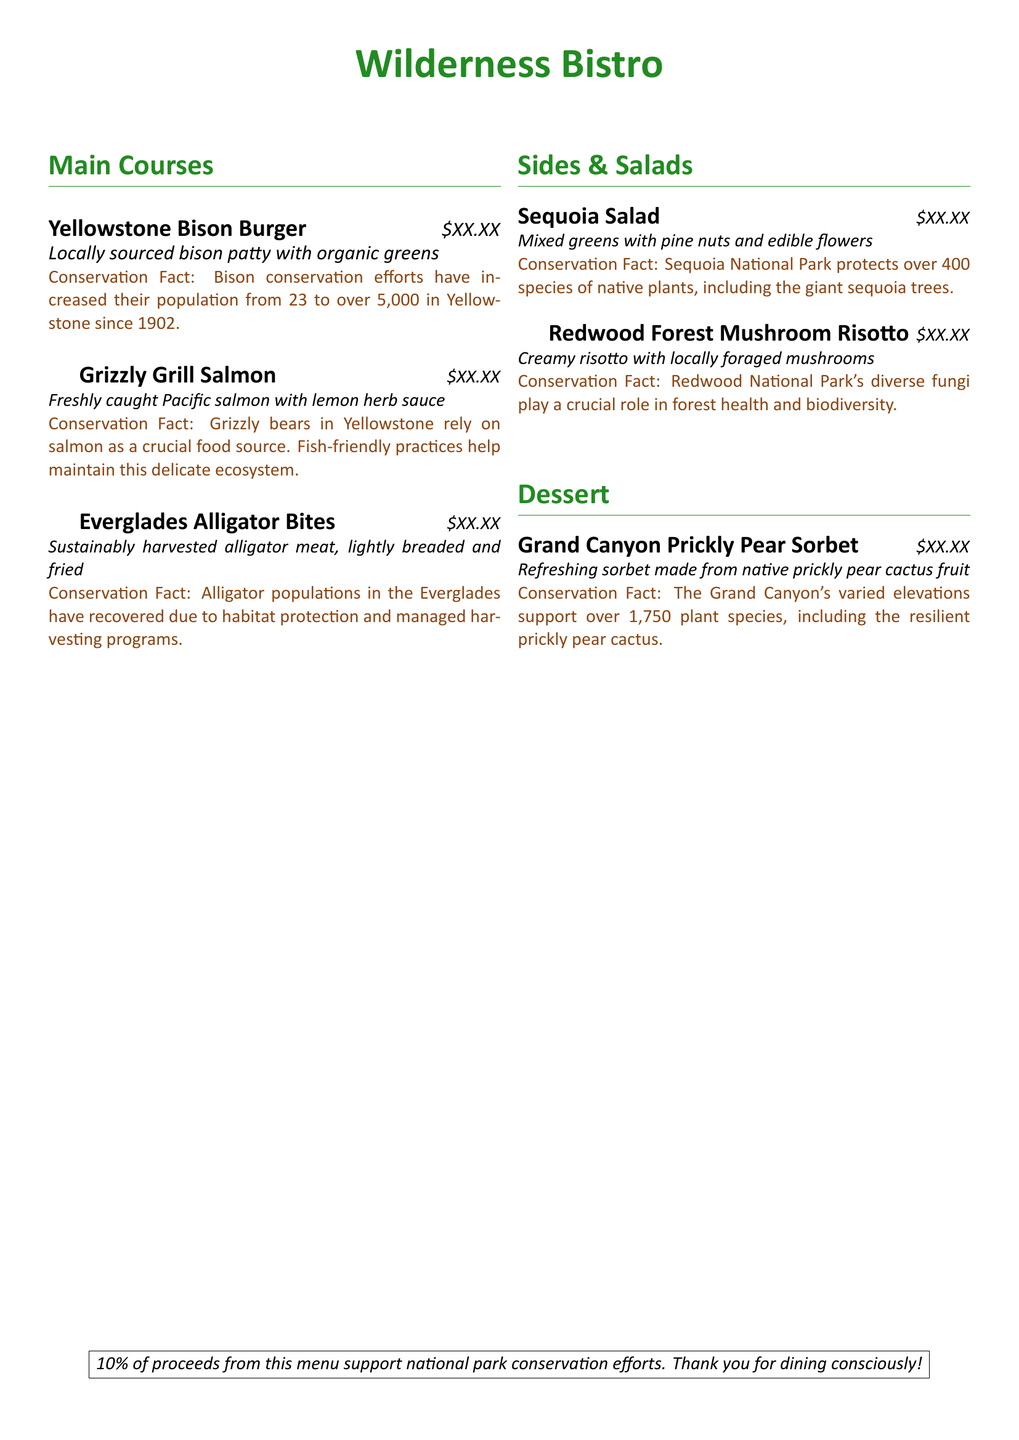What is the price of the Yellowstone Bison Burger? The price is indicated next to the dish name in the menu and is shown as $XX.XX, which is a placeholder for the price.
Answer: $XX.XX How many species of native plants are protected in Sequoia National Park? The conservation fact for the Sequoia Salad states that over 400 species of native plants are protected in Sequoia National Park.
Answer: 400 What is the conservation status of alligator populations in the Everglades? The menu item for Everglades Alligator Bites mentions that alligator populations have recovered due to habitat protection and managed harvesting programs.
Answer: Recovered Which dish contains Pacific salmon? The menu item specifically states that Grizzly Grill Salmon is made with Pacific salmon.
Answer: Grizzly Grill Salmon How much do the proceeds from this menu support conservation efforts? The information regarding the contributions is located in the last section of the document, stating that 10% of proceeds support national park conservation efforts.
Answer: 10% What food source do grizzly bears rely on? The conservation fact for Grizzly Grill Salmon indicates that grizzly bears rely on salmon as a crucial food source.
Answer: Salmon What type of fruit is used in the Grand Canyon Prickly Pear Sorbet? The dessert section states that the sorbet is made from native prickly pear cactus fruit.
Answer: Prickly pear cactus fruit What is the primary ingredient in the Redwood Forest Mushroom Risotto? The item description refers to the use of locally foraged mushrooms as the main component of the risotto.
Answer: Locally foraged mushrooms 